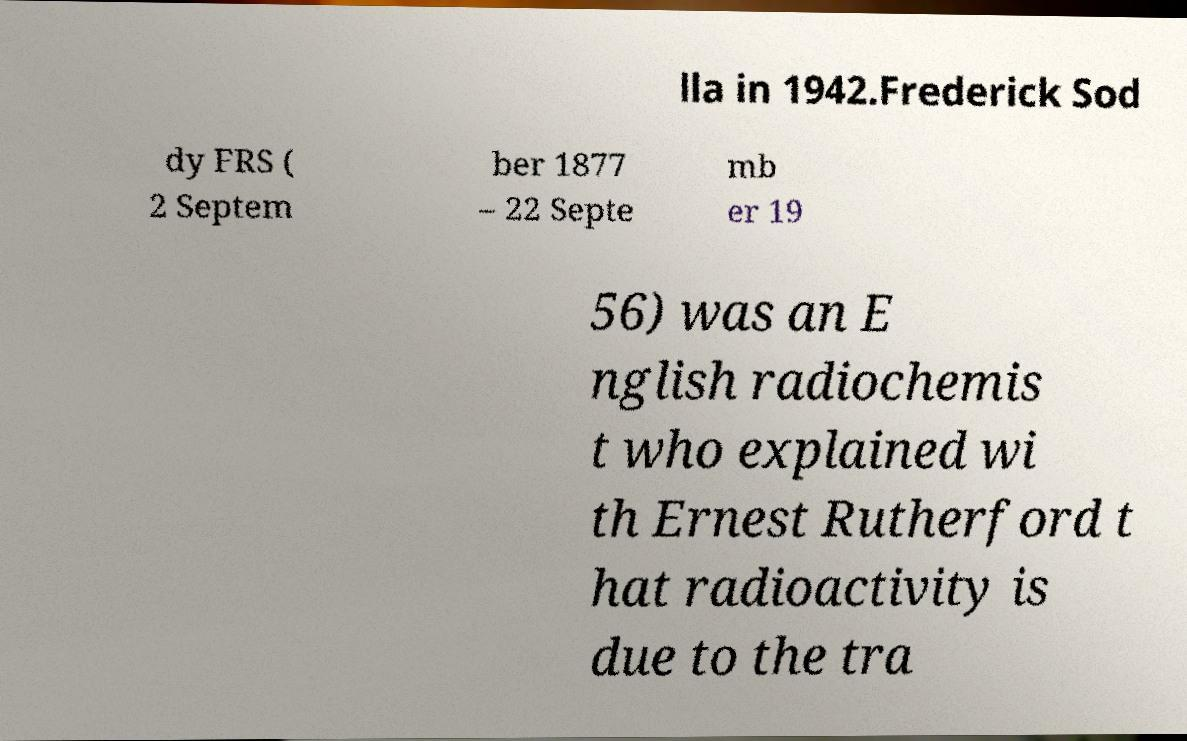Please read and relay the text visible in this image. What does it say? lla in 1942.Frederick Sod dy FRS ( 2 Septem ber 1877 – 22 Septe mb er 19 56) was an E nglish radiochemis t who explained wi th Ernest Rutherford t hat radioactivity is due to the tra 